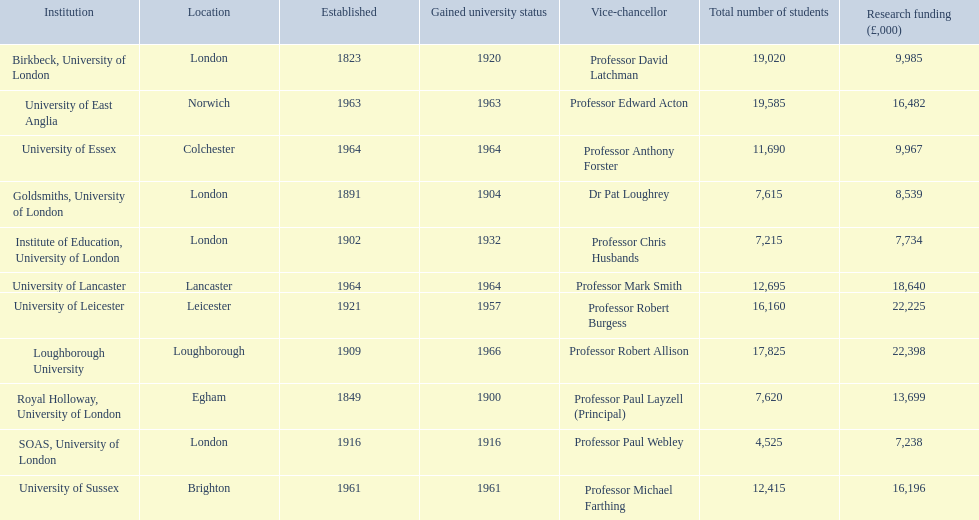What is the location of birkbeck, university of london? London. Which university came into existence in 1921? University of Leicester. Which institution recently received university designation? Loughborough University. 